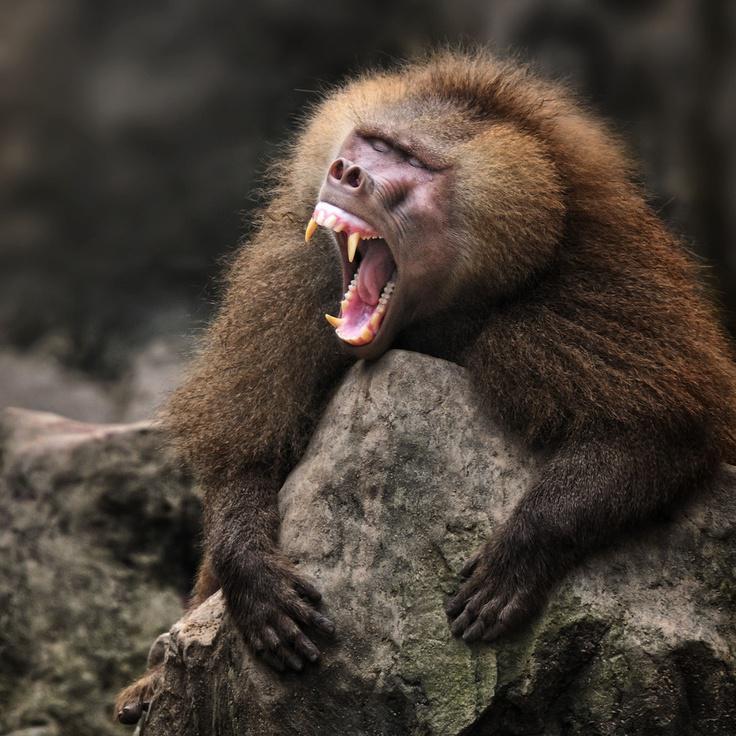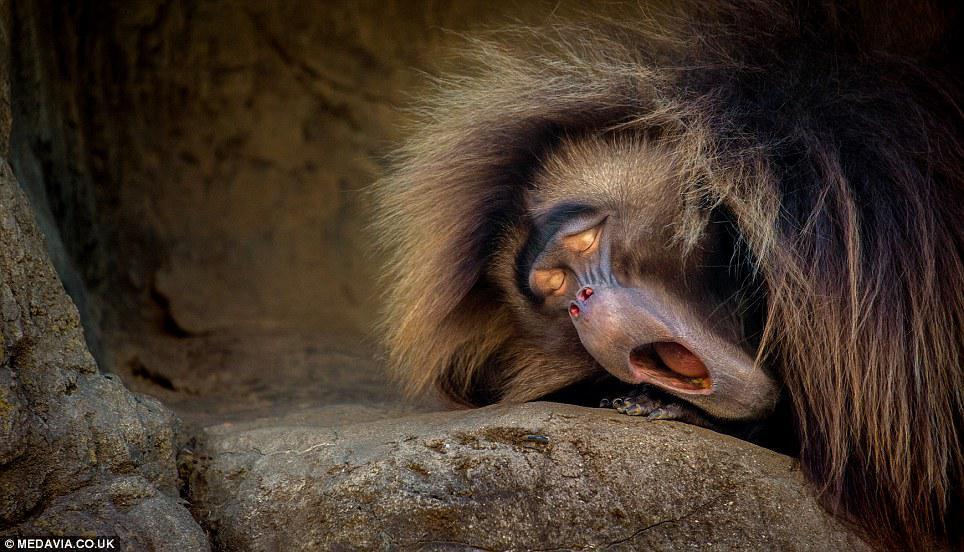The first image is the image on the left, the second image is the image on the right. Analyze the images presented: Is the assertion "An image includes a baboon baring its fangs with wide-opened mouth." valid? Answer yes or no. Yes. The first image is the image on the left, the second image is the image on the right. Assess this claim about the two images: "At least one monkey has its mouth wide open with sharp teeth visible.". Correct or not? Answer yes or no. Yes. 